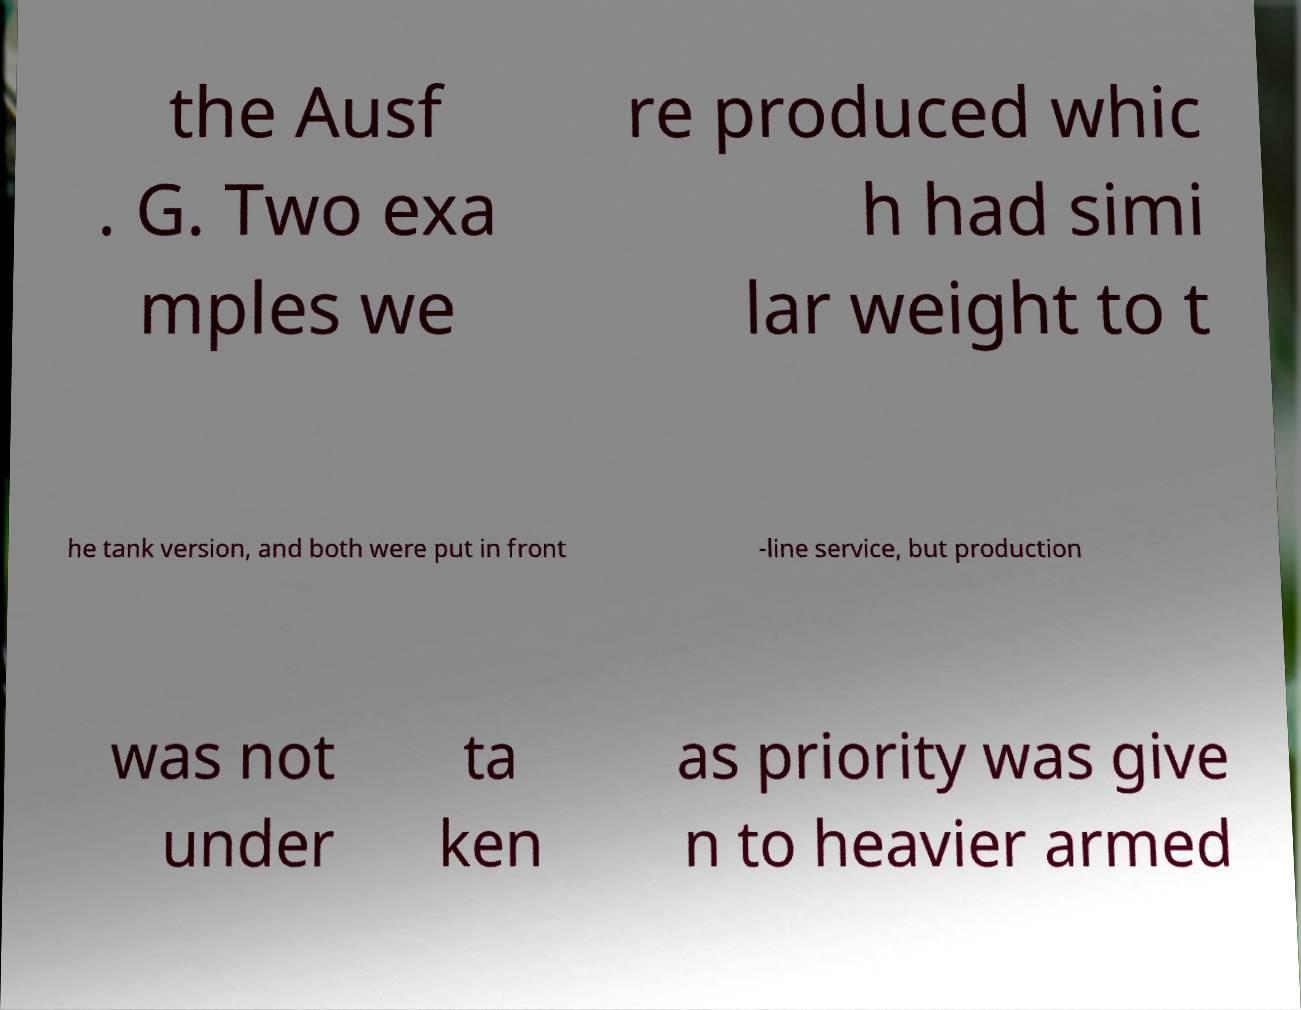Please read and relay the text visible in this image. What does it say? the Ausf . G. Two exa mples we re produced whic h had simi lar weight to t he tank version, and both were put in front -line service, but production was not under ta ken as priority was give n to heavier armed 